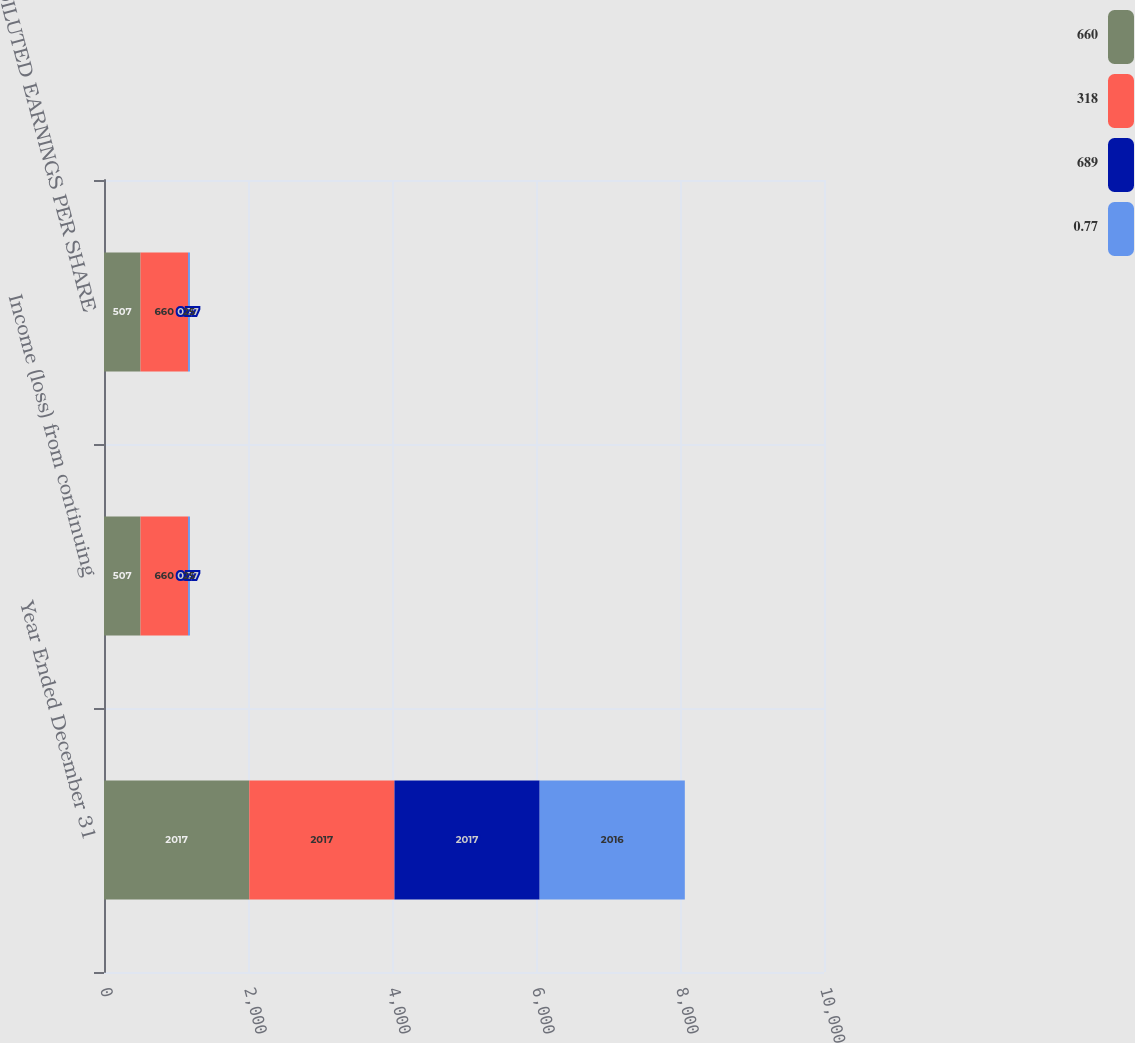Convert chart to OTSL. <chart><loc_0><loc_0><loc_500><loc_500><stacked_bar_chart><ecel><fcel>Year Ended December 31<fcel>Income (loss) from continuing<fcel>DILUTED EARNINGS PER SHARE<nl><fcel>660<fcel>2017<fcel>507<fcel>507<nl><fcel>318<fcel>2017<fcel>660<fcel>660<nl><fcel>689<fcel>2017<fcel>0.77<fcel>0.77<nl><fcel>0.77<fcel>2016<fcel>25<fcel>25<nl></chart> 